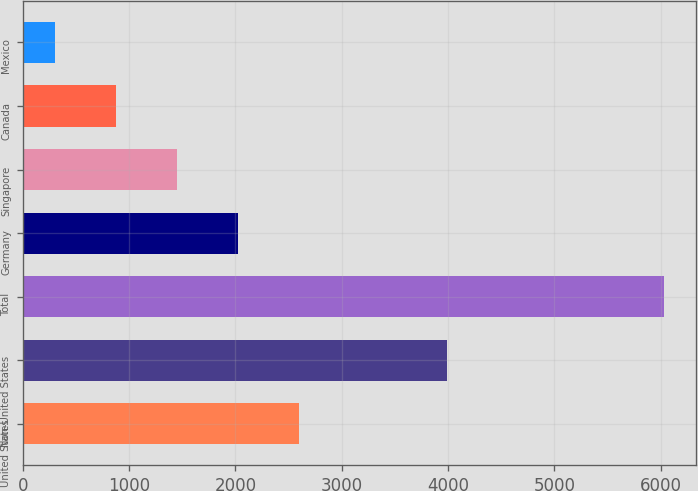Convert chart to OTSL. <chart><loc_0><loc_0><loc_500><loc_500><bar_chart><fcel>United States<fcel>Non-United States<fcel>Total<fcel>Germany<fcel>Singapore<fcel>Canada<fcel>Mexico<nl><fcel>2596.8<fcel>3987<fcel>6033<fcel>2024.1<fcel>1451.4<fcel>878.7<fcel>306<nl></chart> 